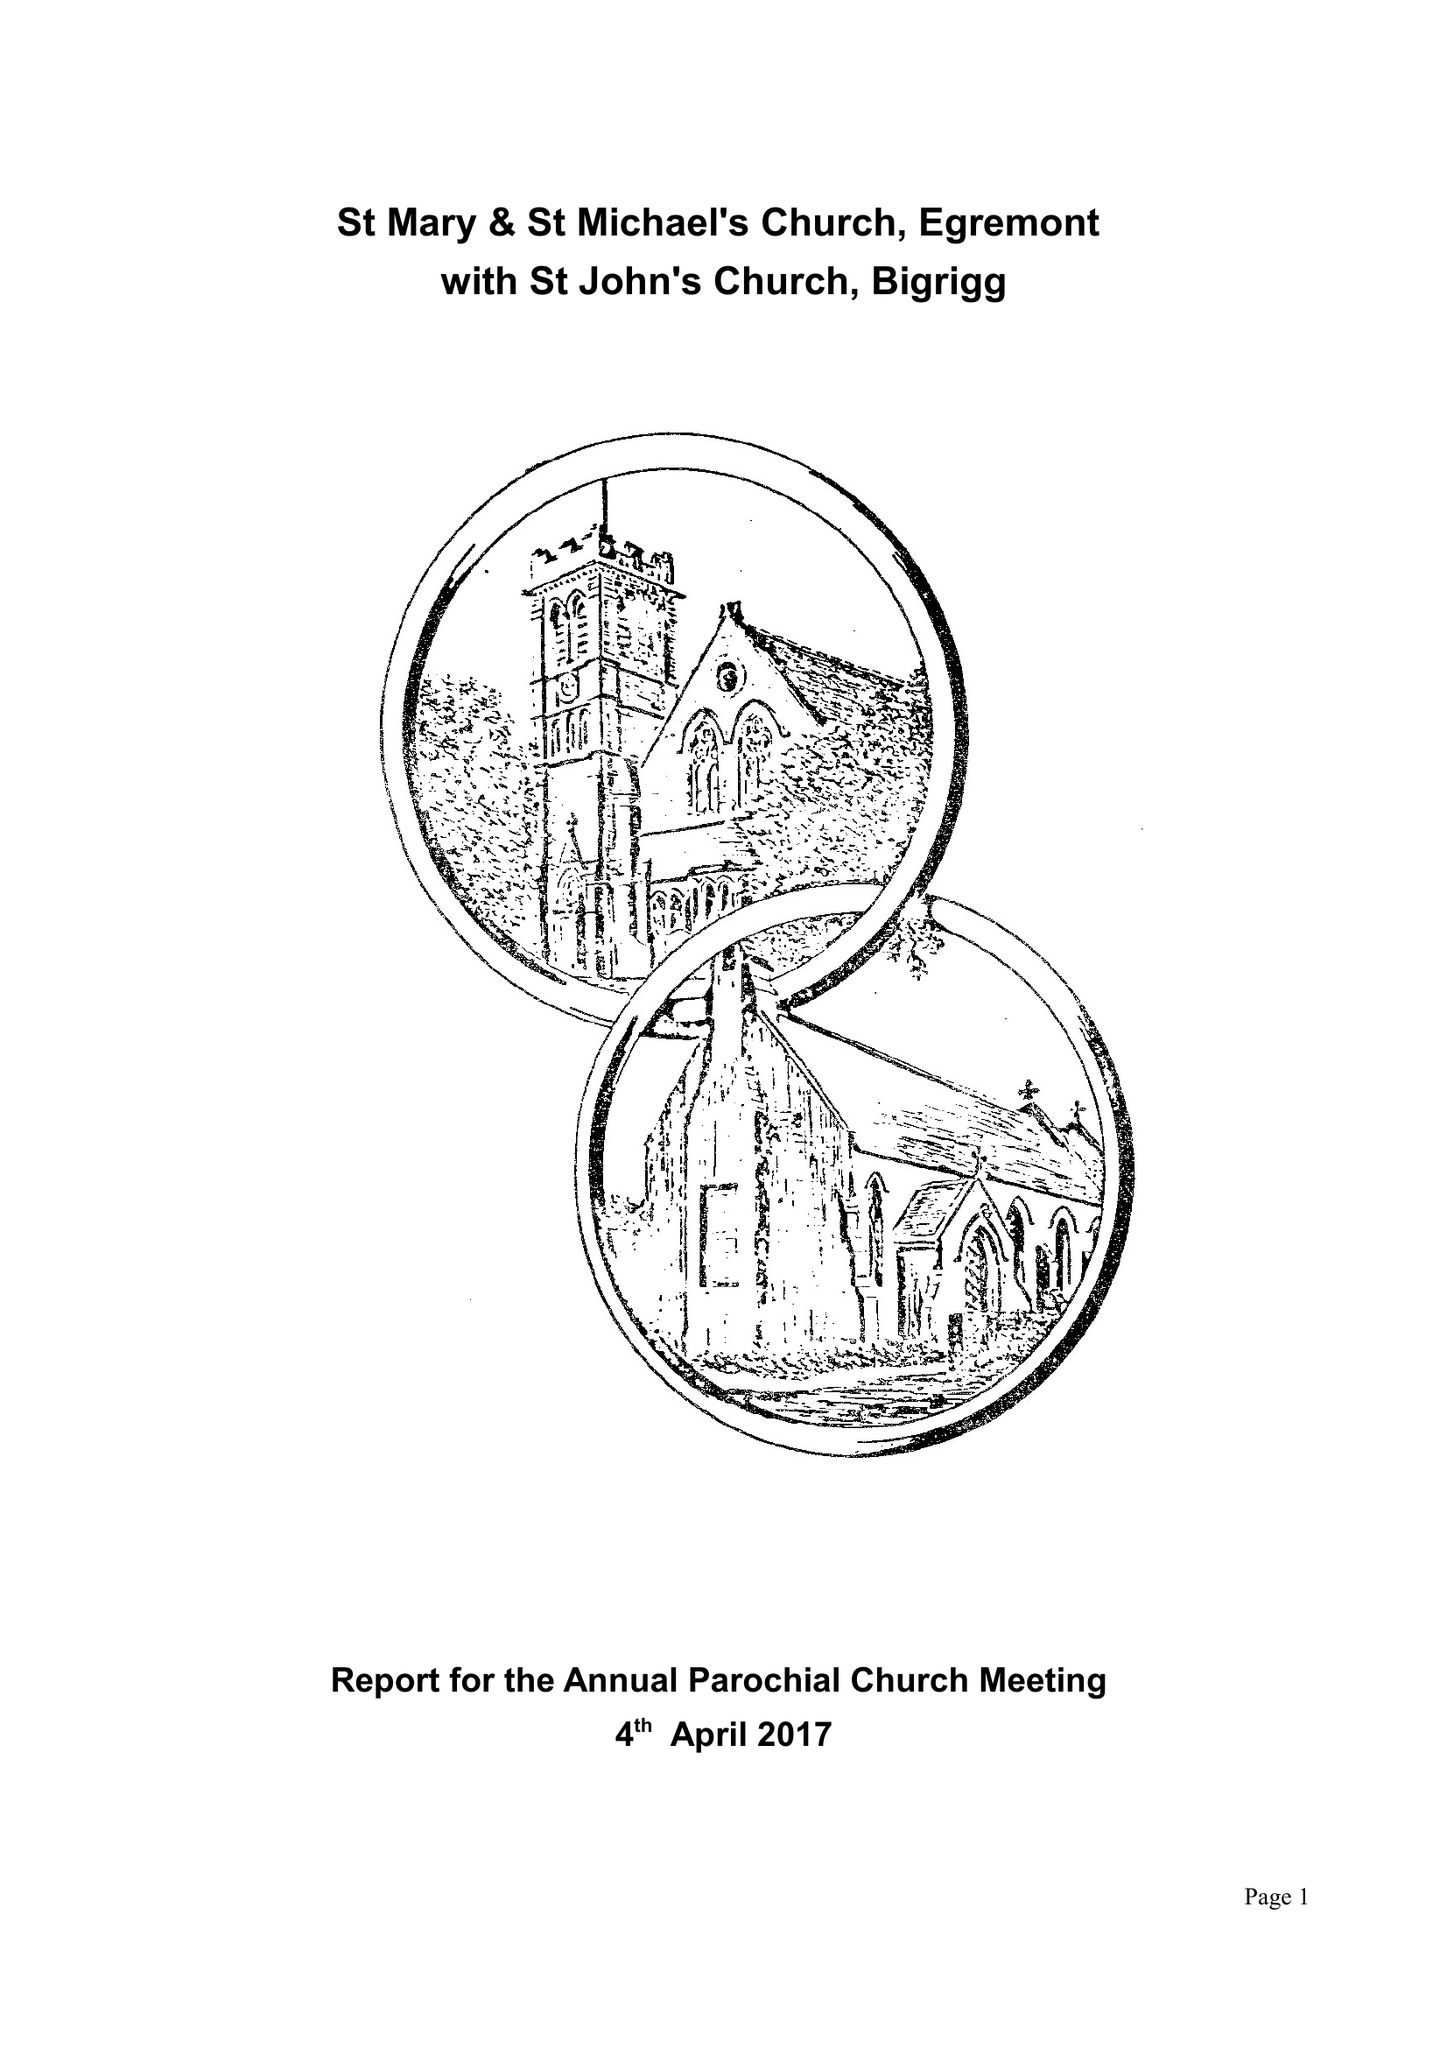What is the value for the report_date?
Answer the question using a single word or phrase. 2016-12-31 